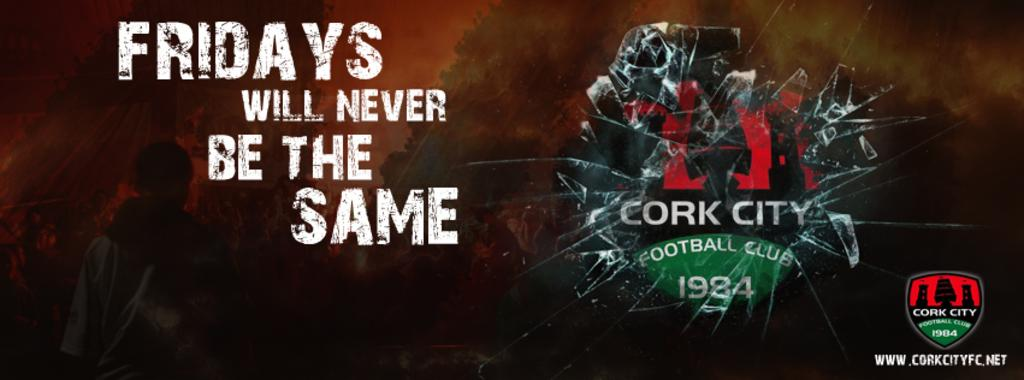<image>
Give a short and clear explanation of the subsequent image. Realistic looking broken glass is on a poster for Cork City Football Club. 